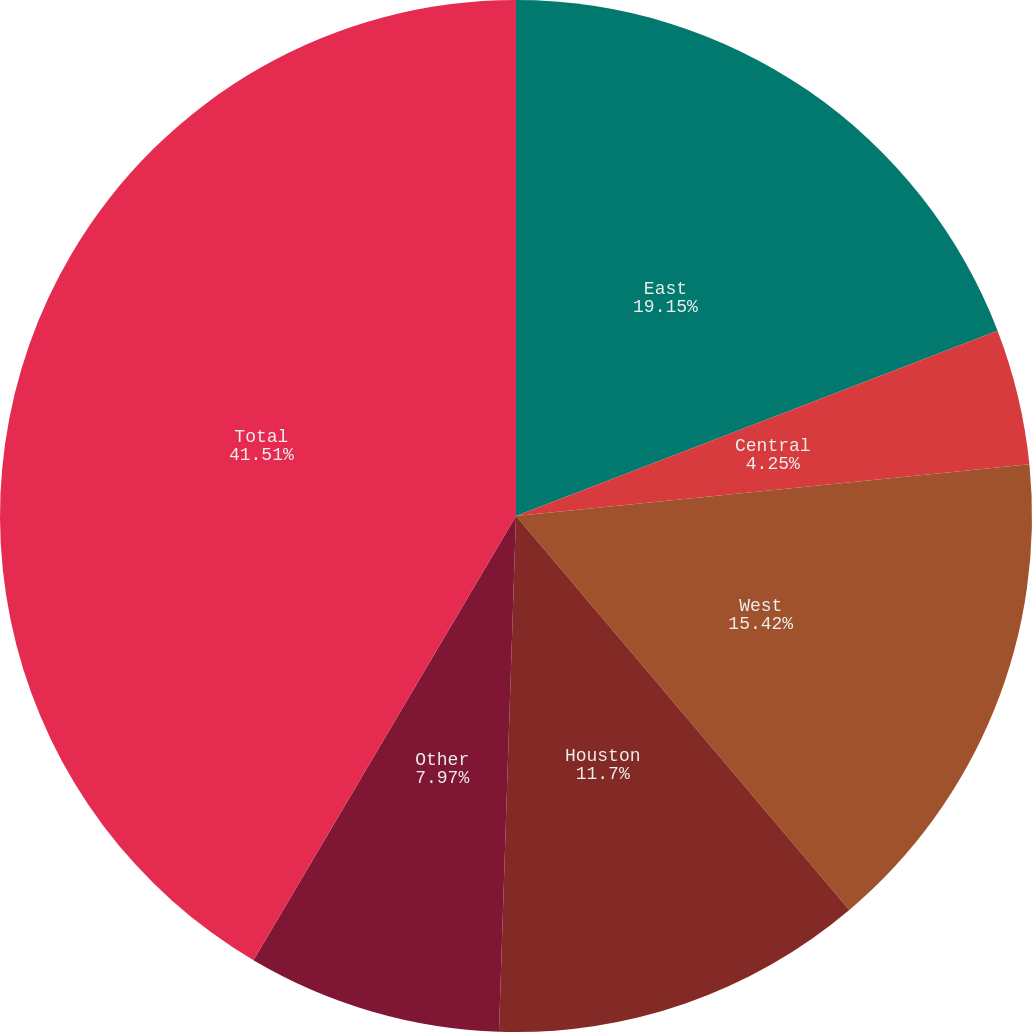Convert chart. <chart><loc_0><loc_0><loc_500><loc_500><pie_chart><fcel>East<fcel>Central<fcel>West<fcel>Houston<fcel>Other<fcel>Total<nl><fcel>19.15%<fcel>4.25%<fcel>15.42%<fcel>11.7%<fcel>7.97%<fcel>41.5%<nl></chart> 